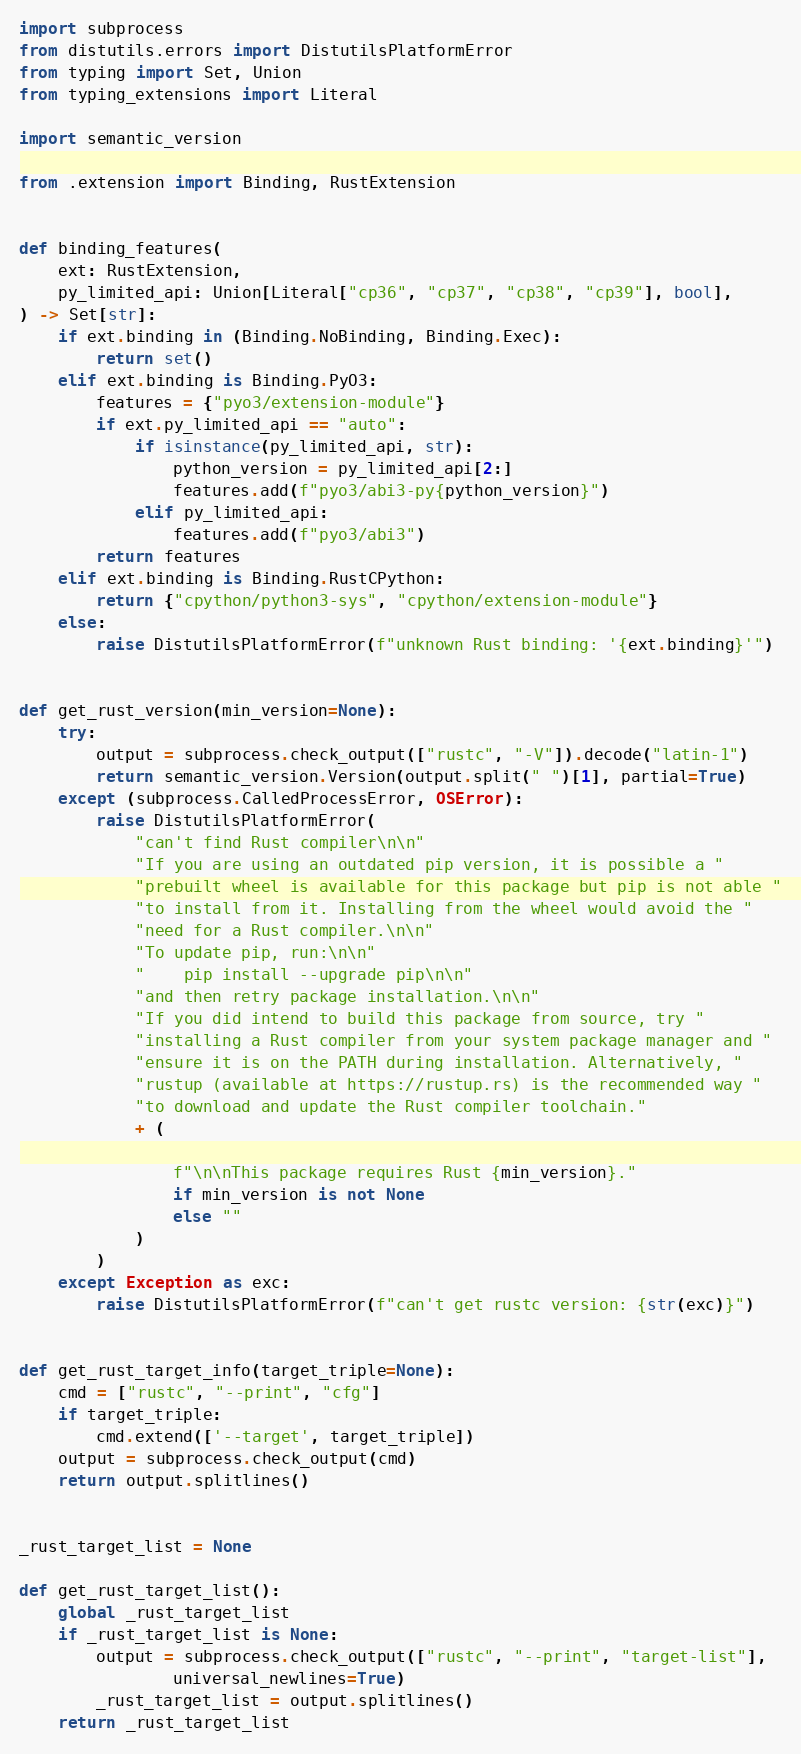Convert code to text. <code><loc_0><loc_0><loc_500><loc_500><_Python_>import subprocess
from distutils.errors import DistutilsPlatformError
from typing import Set, Union
from typing_extensions import Literal

import semantic_version

from .extension import Binding, RustExtension


def binding_features(
    ext: RustExtension,
    py_limited_api: Union[Literal["cp36", "cp37", "cp38", "cp39"], bool],
) -> Set[str]:
    if ext.binding in (Binding.NoBinding, Binding.Exec):
        return set()
    elif ext.binding is Binding.PyO3:
        features = {"pyo3/extension-module"}
        if ext.py_limited_api == "auto":
            if isinstance(py_limited_api, str):
                python_version = py_limited_api[2:]
                features.add(f"pyo3/abi3-py{python_version}")
            elif py_limited_api:
                features.add(f"pyo3/abi3")
        return features
    elif ext.binding is Binding.RustCPython:
        return {"cpython/python3-sys", "cpython/extension-module"}
    else:
        raise DistutilsPlatformError(f"unknown Rust binding: '{ext.binding}'")


def get_rust_version(min_version=None):
    try:
        output = subprocess.check_output(["rustc", "-V"]).decode("latin-1")
        return semantic_version.Version(output.split(" ")[1], partial=True)
    except (subprocess.CalledProcessError, OSError):
        raise DistutilsPlatformError(
            "can't find Rust compiler\n\n"
            "If you are using an outdated pip version, it is possible a "
            "prebuilt wheel is available for this package but pip is not able "
            "to install from it. Installing from the wheel would avoid the "
            "need for a Rust compiler.\n\n"
            "To update pip, run:\n\n"
            "    pip install --upgrade pip\n\n"
            "and then retry package installation.\n\n"
            "If you did intend to build this package from source, try "
            "installing a Rust compiler from your system package manager and "
            "ensure it is on the PATH during installation. Alternatively, "
            "rustup (available at https://rustup.rs) is the recommended way "
            "to download and update the Rust compiler toolchain."
            + (

                f"\n\nThis package requires Rust {min_version}."
                if min_version is not None
                else ""
            )
        )
    except Exception as exc:
        raise DistutilsPlatformError(f"can't get rustc version: {str(exc)}")


def get_rust_target_info(target_triple=None):
    cmd = ["rustc", "--print", "cfg"]
    if target_triple:
        cmd.extend(['--target', target_triple])
    output = subprocess.check_output(cmd)
    return output.splitlines()


_rust_target_list = None

def get_rust_target_list():
    global _rust_target_list
    if _rust_target_list is None:
        output = subprocess.check_output(["rustc", "--print", "target-list"],
                universal_newlines=True)
        _rust_target_list = output.splitlines()
    return _rust_target_list
</code> 